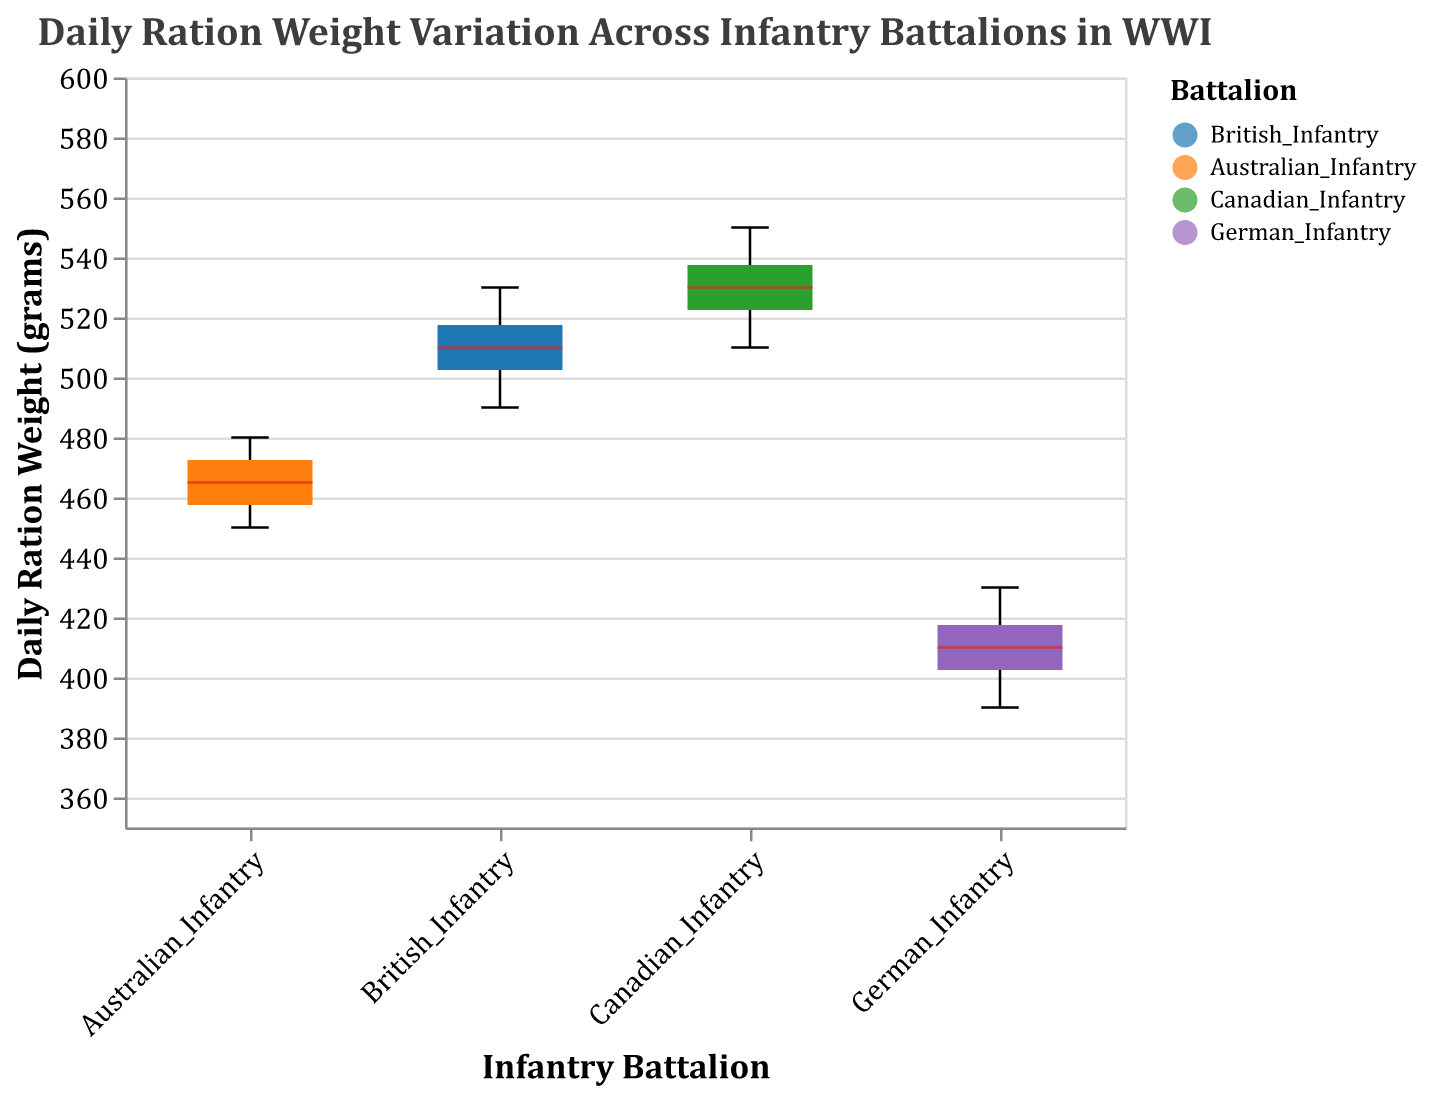What is the title of the figure? The title is text displayed at the top of the figure. It usually provides a summary of what the figure is about. In this case, it reads "Daily Ration Weight Variation Across Infantry Battalions in WWI."
Answer: Daily Ration Weight Variation Across Infantry Battalions in WWI How many battalions are represented in the figure? There are different colored sections in the x-axis labels representing each battalion. In this figure, the battalions named are: British_Infantry, Australian_Infantry, Canadian_Infantry, and German_Infantry, making a total of four battalions.
Answer: Four Which battalion has the highest median daily ration weight? The median value in a box plot is indicated by the line inside the box. By looking at the box plot for each battalion, the Canadian_Infantry has the highest median value, indicated by the highest positioned median line.
Answer: Canadian_Infantry What's the interquartile range of the German_Infantry's daily ration weight? The interquartile range (IQR) is the range between the first quartile (Q1) and the third quartile (Q3) of a box plot. For the German_Infantry, these values can be read from the edges of the box. After identifying Q3 and Q1, subtract Q1 from Q3.
Answer: 420 - 400 = 20 grams Compare the range of daily ration weights between British_Infantry and Australian_Infantry. The range is the difference between the max and min values in a box plot. For British_Infantry it is 530 - 490 = 40 grams, and for Australian_Infantry it is 480 - 450 = 30 grams.
Answer: British_Infantry: 40 grams, Australian_Infantry: 30 grams Which battalion has the least variation in daily ration weights? Variation in a box plot can be observed by looking at the span from the minimum to maximum values (whiskers). The German_Infantry has the shortest span, indicating the least variation.
Answer: German_Infantry What are the median values for each battalion? The median value is marked by a line inside each box in the boxplot. For British_Infantry, it is 510 grams; for Australian_Infantry, it is 465 grams; for Canadian_Infantry, it is 530 grams; and for German_Infantry, it is 410 grams.
Answer: British_Infantry: 510, Australian_Infantry: 465, Canadian_Infantry: 530, German_Infantry: 410 Which battalion's daily ration weights are the most spread out? The battalion with the highest range will have the biggest spread. The Canadian_Infantry’s range is 550 - 510 = 40 grams, which is the largest range among all battalions.
Answer: Canadian_Infantry How does the overall dietary provision compare between German_Infantry and Canadian_Infantry? Comparison can be made using the median values and the spread. The German_Infantry has a much lower median daily ration weight (410 grams) compared to Canadian_Infantry (530 grams), and also a narrower spread indicating less variation in their ration weights.
Answer: Canadian_Infantry has more and varied rations compared to German_Infantry 